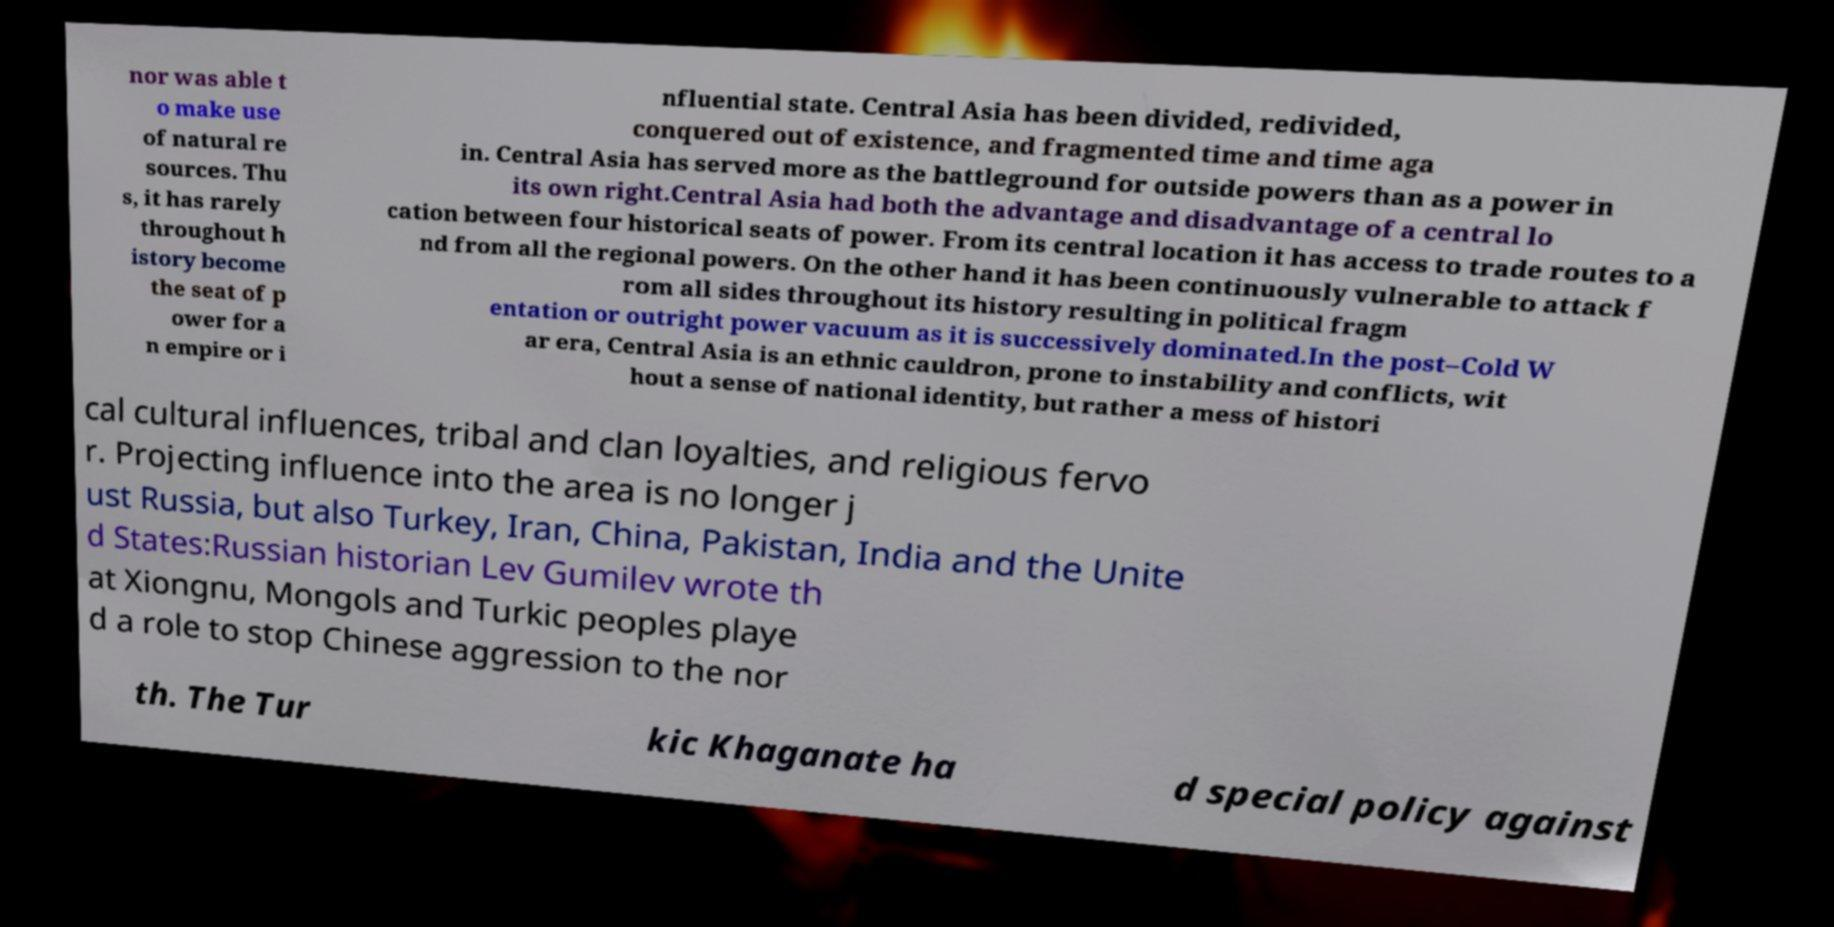Please read and relay the text visible in this image. What does it say? nor was able t o make use of natural re sources. Thu s, it has rarely throughout h istory become the seat of p ower for a n empire or i nfluential state. Central Asia has been divided, redivided, conquered out of existence, and fragmented time and time aga in. Central Asia has served more as the battleground for outside powers than as a power in its own right.Central Asia had both the advantage and disadvantage of a central lo cation between four historical seats of power. From its central location it has access to trade routes to a nd from all the regional powers. On the other hand it has been continuously vulnerable to attack f rom all sides throughout its history resulting in political fragm entation or outright power vacuum as it is successively dominated.In the post–Cold W ar era, Central Asia is an ethnic cauldron, prone to instability and conflicts, wit hout a sense of national identity, but rather a mess of histori cal cultural influences, tribal and clan loyalties, and religious fervo r. Projecting influence into the area is no longer j ust Russia, but also Turkey, Iran, China, Pakistan, India and the Unite d States:Russian historian Lev Gumilev wrote th at Xiongnu, Mongols and Turkic peoples playe d a role to stop Chinese aggression to the nor th. The Tur kic Khaganate ha d special policy against 